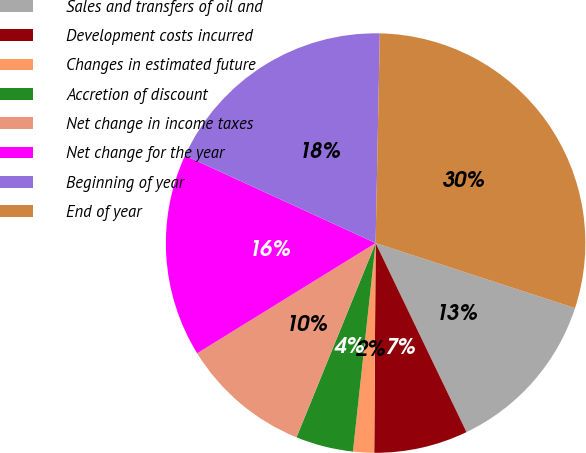Convert chart. <chart><loc_0><loc_0><loc_500><loc_500><pie_chart><fcel>Sales and transfers of oil and<fcel>Development costs incurred<fcel>Changes in estimated future<fcel>Accretion of discount<fcel>Net change in income taxes<fcel>Net change for the year<fcel>Beginning of year<fcel>End of year<nl><fcel>12.85%<fcel>7.24%<fcel>1.62%<fcel>4.43%<fcel>10.04%<fcel>15.66%<fcel>18.47%<fcel>29.7%<nl></chart> 